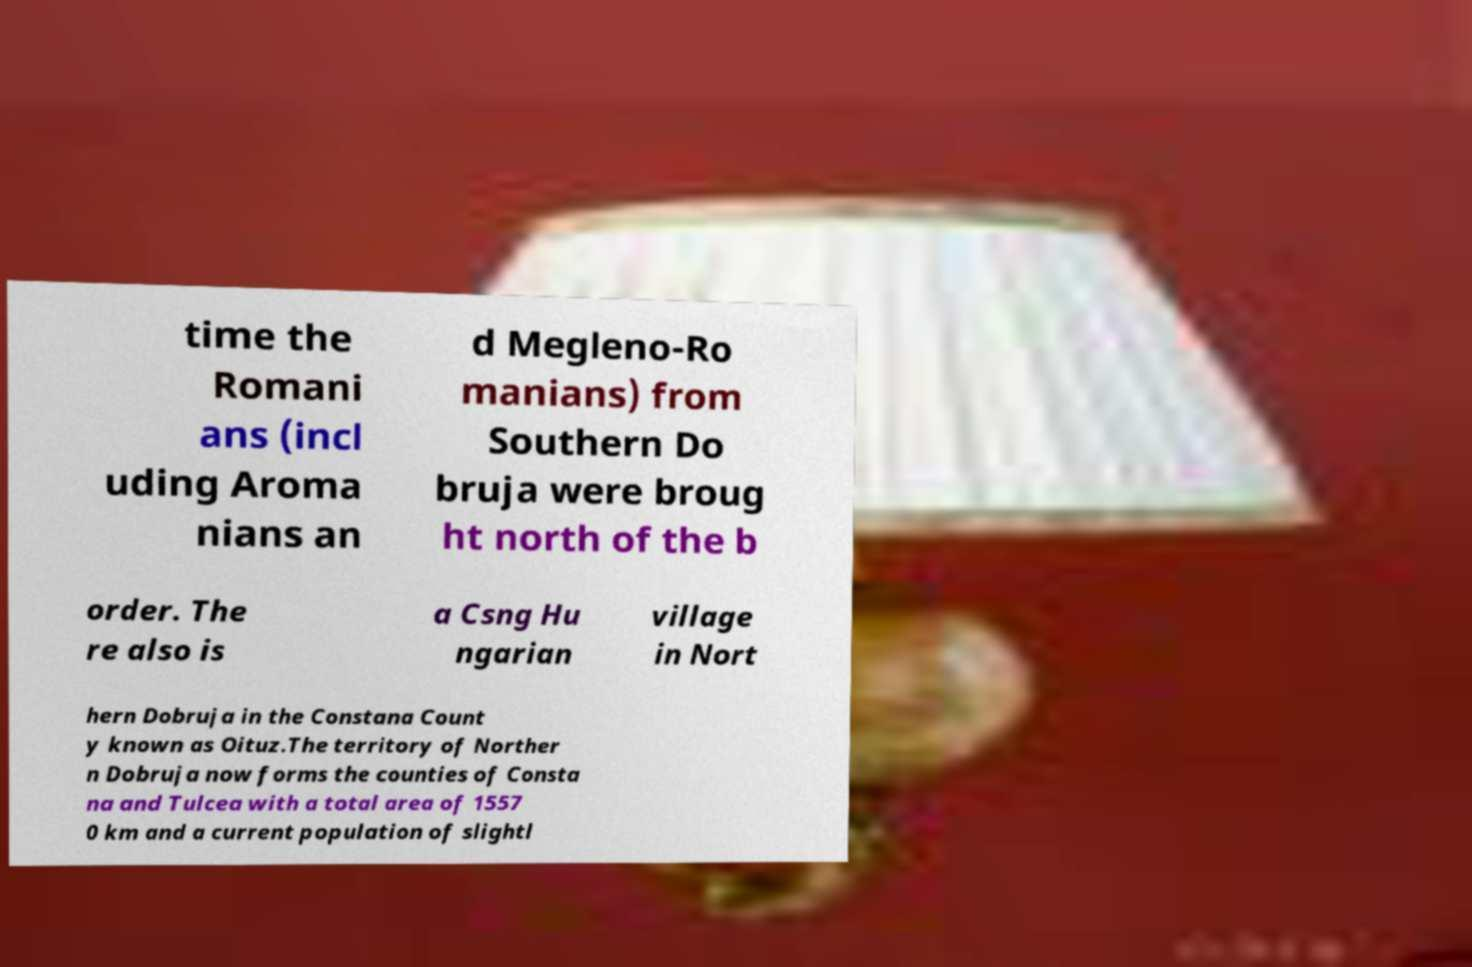Can you accurately transcribe the text from the provided image for me? time the Romani ans (incl uding Aroma nians an d Megleno-Ro manians) from Southern Do bruja were broug ht north of the b order. The re also is a Csng Hu ngarian village in Nort hern Dobruja in the Constana Count y known as Oituz.The territory of Norther n Dobruja now forms the counties of Consta na and Tulcea with a total area of 1557 0 km and a current population of slightl 